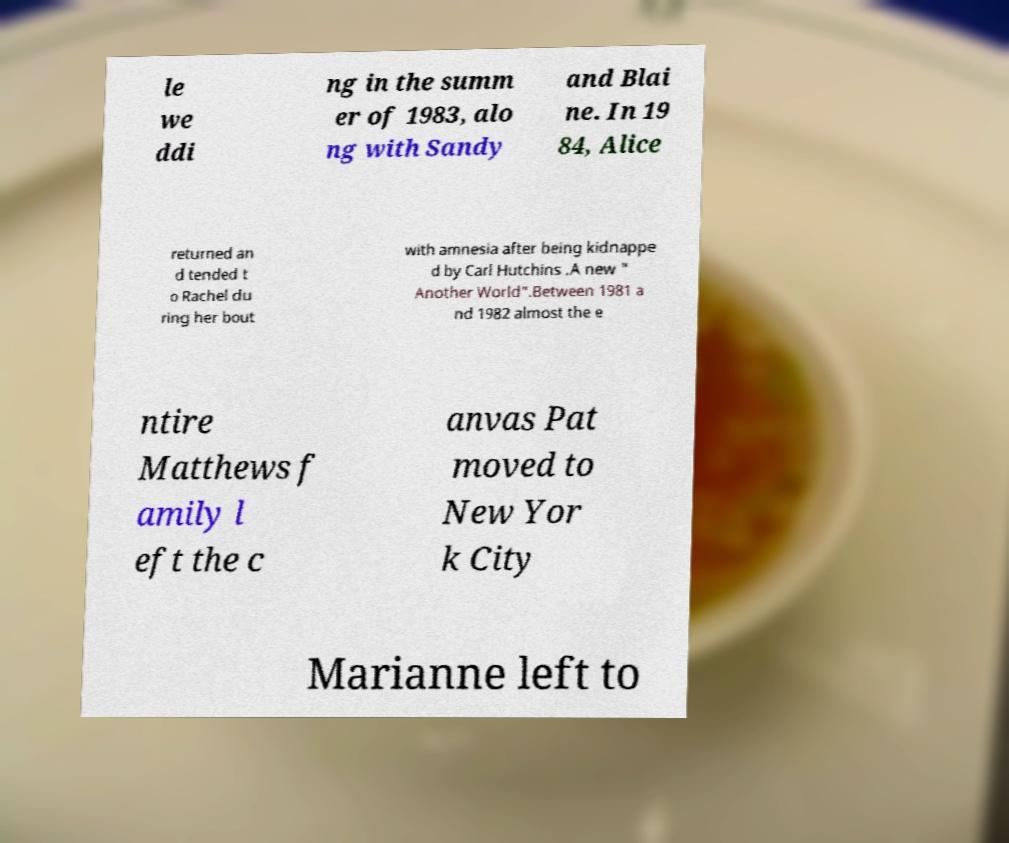Please read and relay the text visible in this image. What does it say? le we ddi ng in the summ er of 1983, alo ng with Sandy and Blai ne. In 19 84, Alice returned an d tended t o Rachel du ring her bout with amnesia after being kidnappe d by Carl Hutchins .A new " Another World".Between 1981 a nd 1982 almost the e ntire Matthews f amily l eft the c anvas Pat moved to New Yor k City Marianne left to 